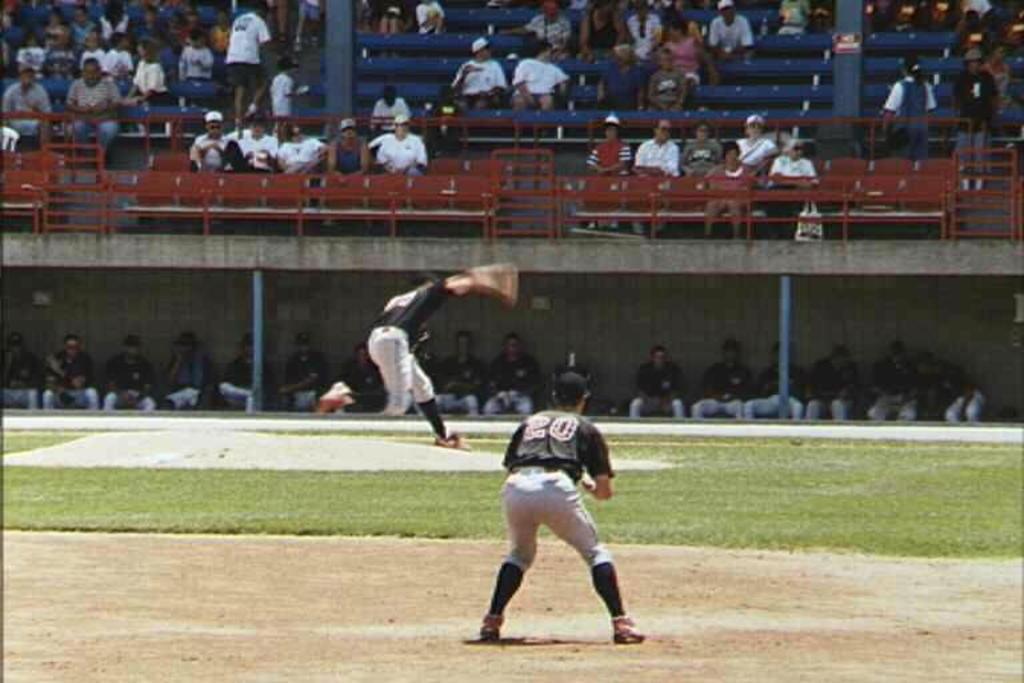What is the frontmost player's number?
Give a very brief answer. 20. 